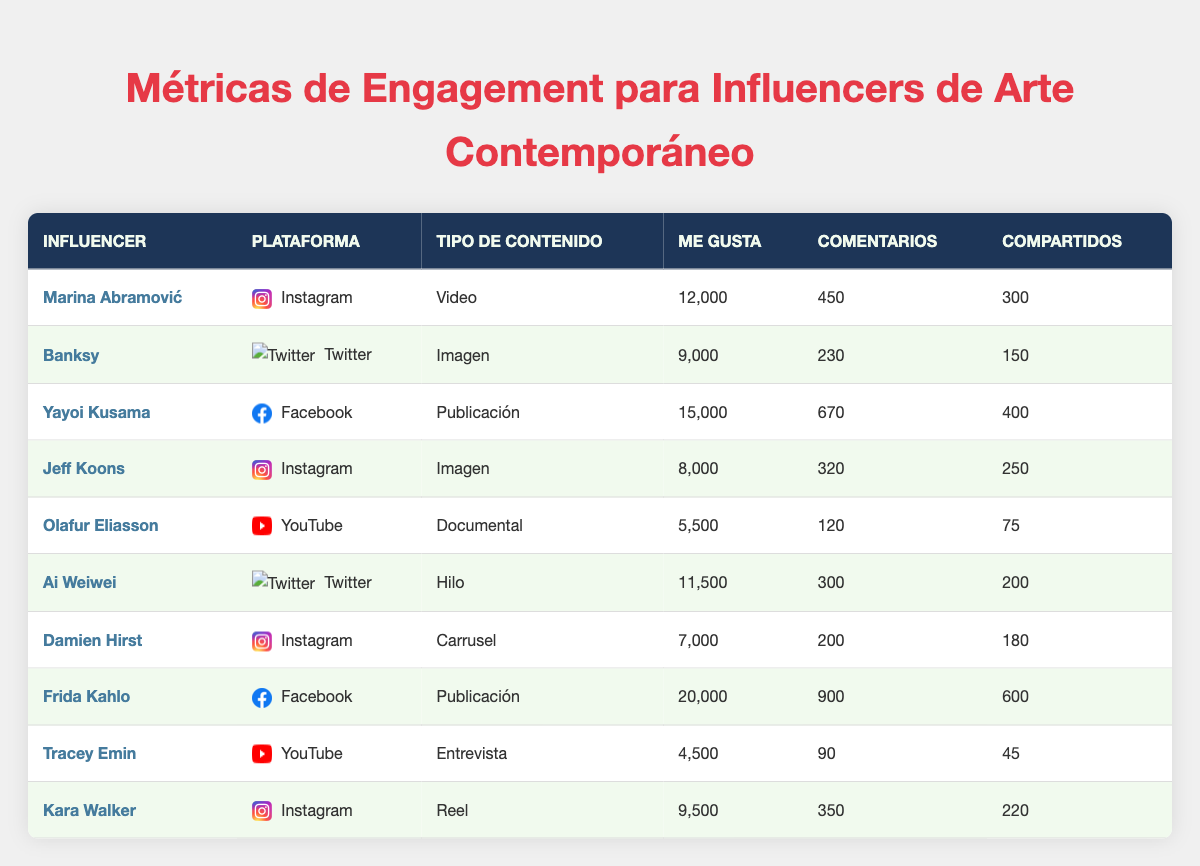What influencer received the most likes on their content? By looking at the "Likes" column in the table, we can see that Frida Kahlo received 20,000 likes for her post on Facebook, which is the highest value in the dataset.
Answer: Frida Kahlo Which platform had the highest engagement for the influencer Marina Abramović? Marina Abramović's engagement metrics are on Instagram with 12,000 likes, 450 comments, and 300 shares. Since no other influencer on Instagram has a higher likes count than her, it confirms that Instagram is the platform with her highest engagement.
Answer: Instagram What is the total number of shares for all influencers on Instagram? To find the total shares for Instagram, we add up the shares from Marina Abramović, Jeff Koons, Damien Hirst, and Kara Walker: 300 + 250 + 180 + 220 = 950.
Answer: 950 Did any influencer on Twitter receive more likes than Ai Weiwei? The only influencers on Twitter in this dataset are Banksy and Ai Weiwei. Banksy has 9,000 likes, while Ai Weiwei has 11,500 likes, showing Ai Weiwei has more likes than Banksy. Thus, the answer is yes.
Answer: Yes Comparing the engagement metrics, which content type has the highest average likes? To find the average likes per content type, we need to break down likes by each type: Video (12,000), Image (8000 + 9000 = 17,000, average 8,500), Post (15,000 + 20,000 = 35,000, average 17,500), Documentary (5,500), Thread (11,500), Carousel (7,000), Interview (4,500), Reel (9,500). Averaging "Post" gives the highest at 17,500 likes, thus it has the highest average likes.
Answer: Post What is the difference in the number of comments between the most and least engaging influencer? Frida Kahlo has the most comments with 900, and Tracey Emin has the least with 90. We calculate the difference: 900 - 90 = 810.
Answer: 810 Which influencer produced a documentary, and how many likes did it receive? The table shows that Olafur Eliasson produced a documentary on YouTube, and it received 5,500 likes.
Answer: Olafur Eliasson, 5,500 likes Did Kara Walker's "Reel" post have more likes than Jeff Koons' "Image"? Kara Walker's "Reel" received 9,500 likes, whereas Jeff Koons' "Image" received 8,000 likes. Since 9,500 is greater than 8,000, the answer is yes.
Answer: Yes What is the average number of comments across the YouTube posts by influencers? The influencers with YouTube posts are Olafur Eliasson with 120 comments and Tracey Emin with 90 comments. We compute the average: (120 + 90) / 2 = 105.
Answer: 105 